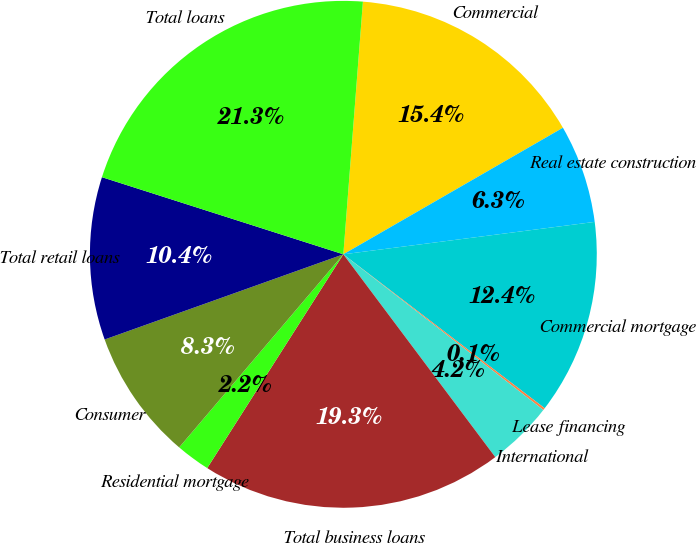<chart> <loc_0><loc_0><loc_500><loc_500><pie_chart><fcel>Commercial<fcel>Real estate construction<fcel>Commercial mortgage<fcel>Lease financing<fcel>International<fcel>Total business loans<fcel>Residential mortgage<fcel>Consumer<fcel>Total retail loans<fcel>Total loans<nl><fcel>15.45%<fcel>6.28%<fcel>12.43%<fcel>0.14%<fcel>4.24%<fcel>19.26%<fcel>2.19%<fcel>8.33%<fcel>10.38%<fcel>21.31%<nl></chart> 